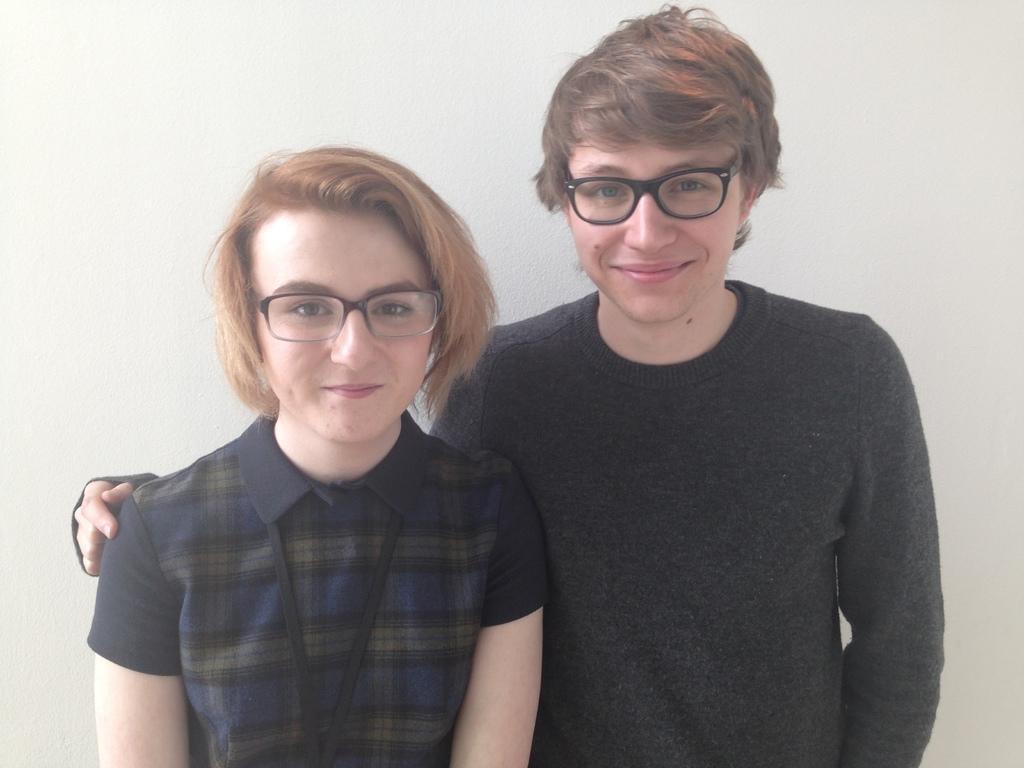Can you describe this image briefly? In this image we can see two people wearing spectacles and standing and there is a wall in the background. 